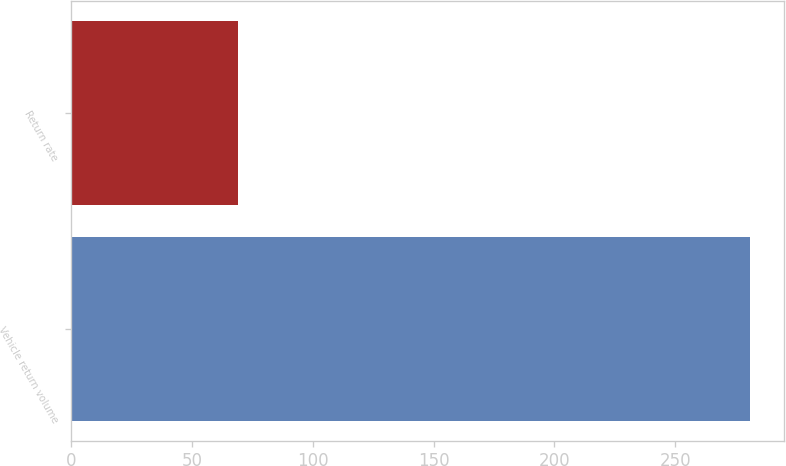<chart> <loc_0><loc_0><loc_500><loc_500><bar_chart><fcel>Vehicle return volume<fcel>Return rate<nl><fcel>281<fcel>69<nl></chart> 